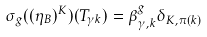<formula> <loc_0><loc_0><loc_500><loc_500>\sigma _ { g } ( ( \eta _ { B } ) ^ { K } ) ( T _ { \gamma k } ) = \beta _ { \gamma , k } ^ { g } \delta _ { K , \pi ( k ) }</formula> 